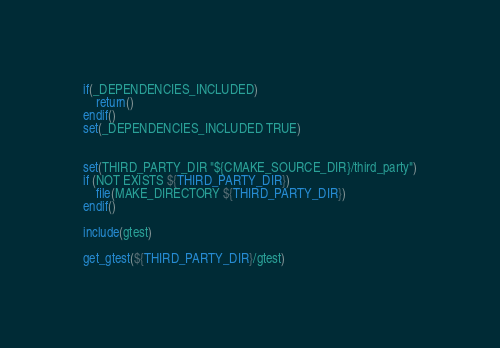<code> <loc_0><loc_0><loc_500><loc_500><_CMake_>if(_DEPENDENCIES_INCLUDED)
    return()
endif()
set(_DEPENDENCIES_INCLUDED TRUE)


set(THIRD_PARTY_DIR "${CMAKE_SOURCE_DIR}/third_party")
if (NOT EXISTS ${THIRD_PARTY_DIR})
    file(MAKE_DIRECTORY ${THIRD_PARTY_DIR})
endif()

include(gtest)

get_gtest(${THIRD_PARTY_DIR}/gtest)
</code> 